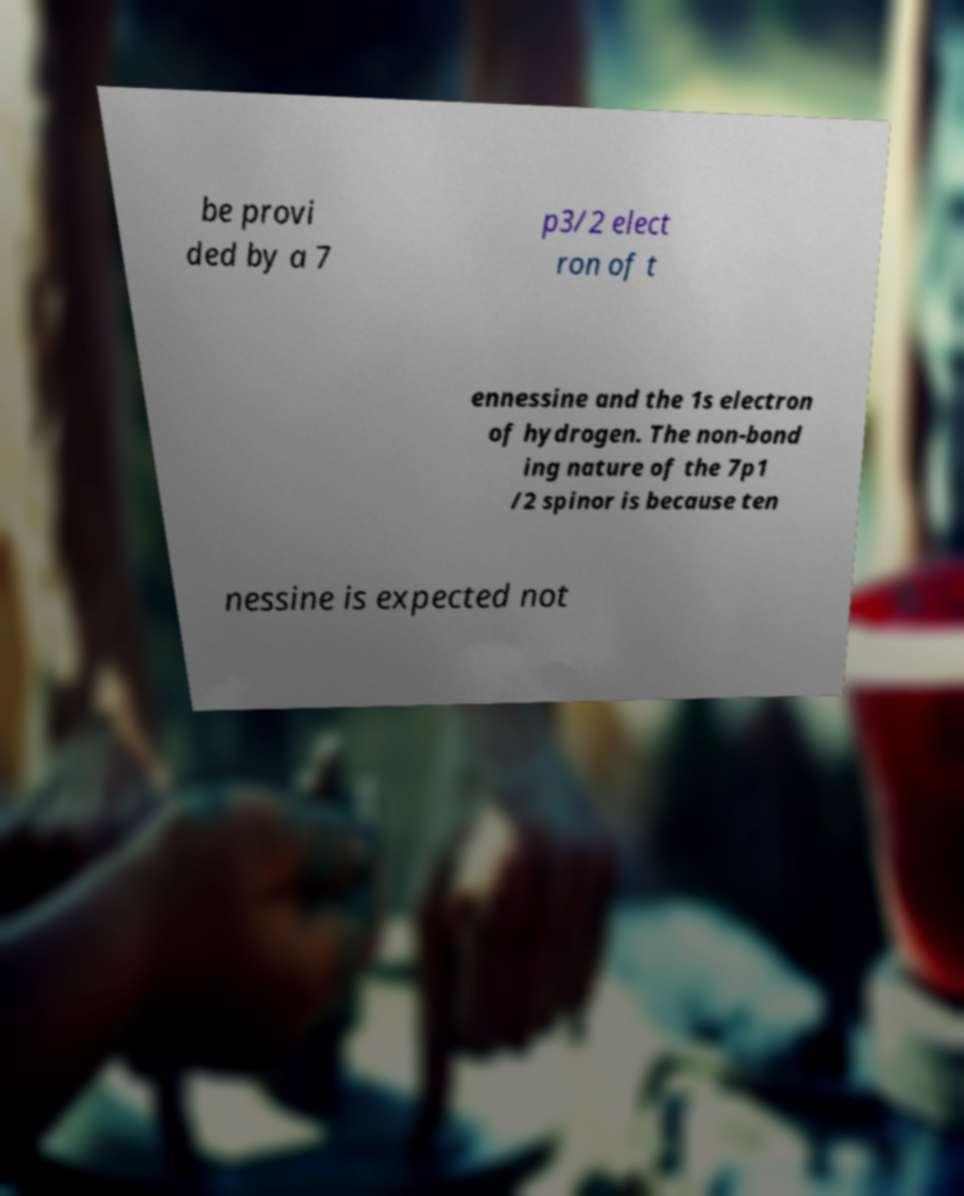Could you extract and type out the text from this image? be provi ded by a 7 p3/2 elect ron of t ennessine and the 1s electron of hydrogen. The non-bond ing nature of the 7p1 /2 spinor is because ten nessine is expected not 